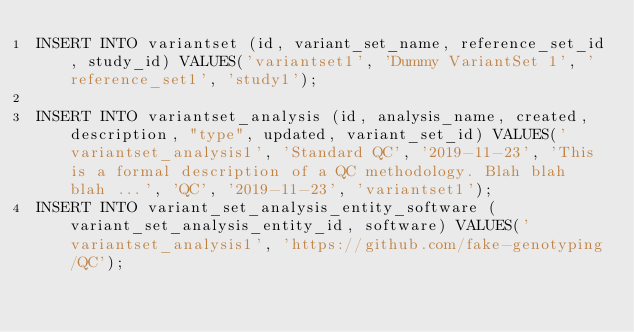Convert code to text. <code><loc_0><loc_0><loc_500><loc_500><_SQL_>INSERT INTO variantset (id, variant_set_name, reference_set_id, study_id) VALUES('variantset1', 'Dummy VariantSet 1', 'reference_set1', 'study1');

INSERT INTO variantset_analysis (id, analysis_name, created, description, "type", updated, variant_set_id) VALUES('variantset_analysis1', 'Standard QC', '2019-11-23', 'This is a formal description of a QC methodology. Blah blah blah ...', 'QC', '2019-11-23', 'variantset1');
INSERT INTO variant_set_analysis_entity_software (variant_set_analysis_entity_id, software) VALUES('variantset_analysis1', 'https://github.com/fake-genotyping/QC');</code> 